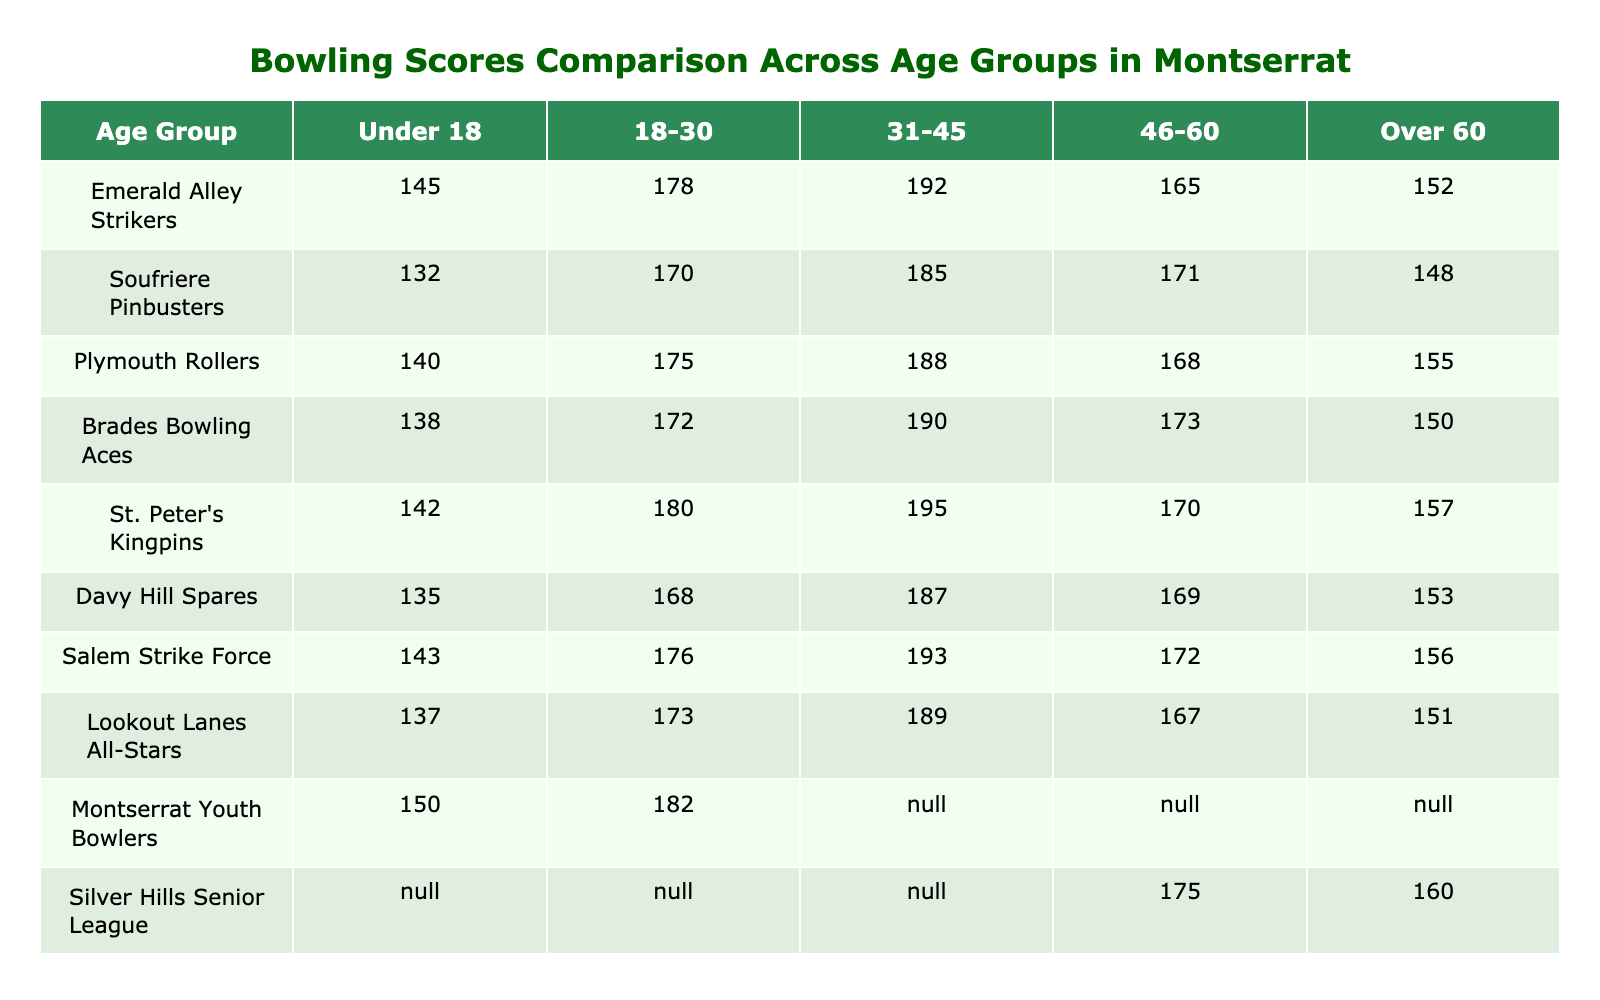What is the highest score recorded for the age group 31-45? By reviewing the data in the '31-45' column, the scores are 192, 185, 188, 190, 195, 187, 193, 189, N/A, and N/A. The highest score among these is 195 from St. Peter's Kingpins.
Answer: 195 What is the average score for the Over 60 age group? To find the average score for the 'Over 60' age group, first, we list the valid scores: 152, 148, 155, 150, 157, 153, 156, 160. There are 8 valid scores. Adding them gives: (152 + 148 + 155 + 150 + 157 + 153 + 156 + 160) = 1221. Now, divide by 8: 1221 / 8 = 152.625. Rounded, that gives an average of approximately 153.
Answer: 153 Which team has the lowest score in the Under 18 age group? Looking at the scores in the 'Under 18' column, the scores are 145, 132, 140, 138, 142, 135, 143, 137, 150, and N/A. The lowest score is 132 recorded by Soufriere Pinbusters.
Answer: 132 Is there any team that has no data for the age groups under 31? Reviewing the teams listed, Montserrat Youth Bowlers has N/A in the 31-45 and Over 60 age group. Additionally, Silver Hills Senior League has N/A in the Under 18 and 18-30 age groups. Hence, the answer is yes as Montserrat Youth Bowlers has two missing values and one team has two N/A.
Answer: Yes What is the total score for the Emerald Alley Strikers across all age groups? Summing the scores from the Emerald Alley Strikers across all available age groups: 145 (Under 18) + 178 (18-30) + 192 (31-45) + 165 (46-60) + 152 (Over 60) = 832.
Answer: 832 Which age group has the most consistent scores across the teams? Analyzing the standard deviation of scores for each age group can identify consistency. By reviewing the scores for each age group: Under 18: (145, 132, 140, 138, 142, 135, 143, 137, 150), 18-30: (178, 170, 175, 172, 180, 168, 176, 173), 31-45: (192, 185, 188, 190, 195, 187, 193, 189), 46-60: (165, 171, 168, 173, 170, 169, 172, 167), Over 60: (152, 148, 155, 150, 157, 153, 156, 160). The variability in scores indicates that the Over 60 group has the smallest range and thus may be most consistent.
Answer: Over 60 What is the difference in score between the highest and the lowest for the 18-30 age group? Calculating the scores in the '18-30' column gives us: 178, 170, 175, 172, 180, 168, 176, and 173. The highest score is 180 and the lowest is 168. The difference is: 180 - 168 = 12.
Answer: 12 